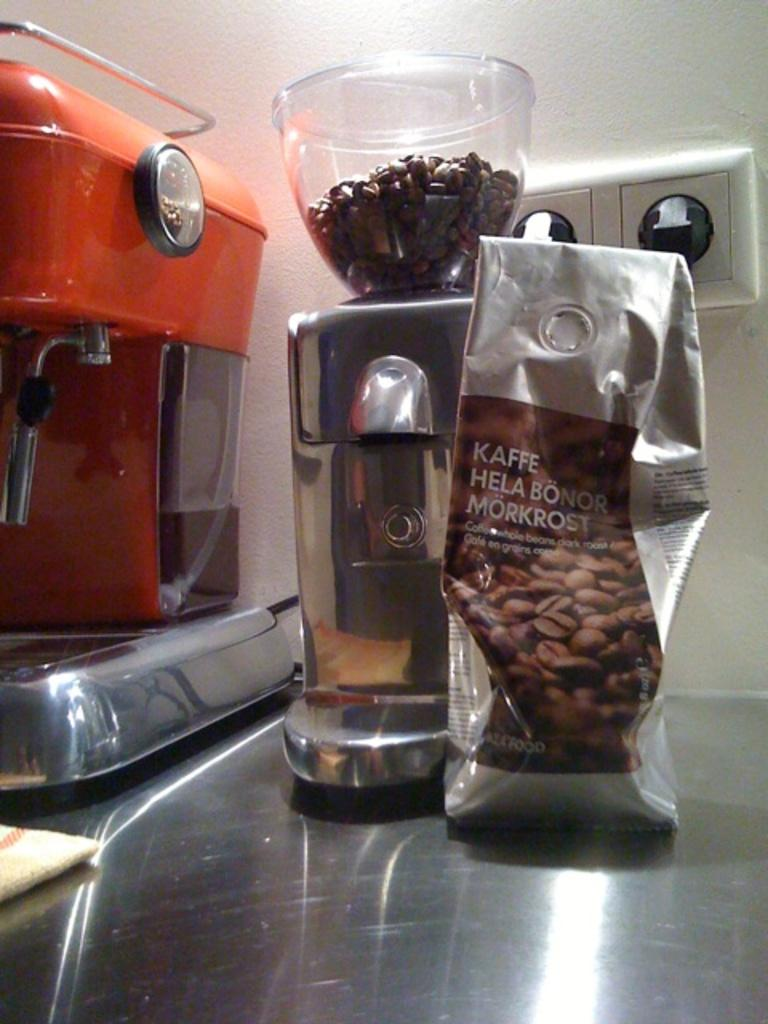<image>
Create a compact narrative representing the image presented. A bag of coffee beans that says Kaffe Hela Bonor Morkrost on the bag and a coffee grinder is beside the bag filled with coffee beans. 